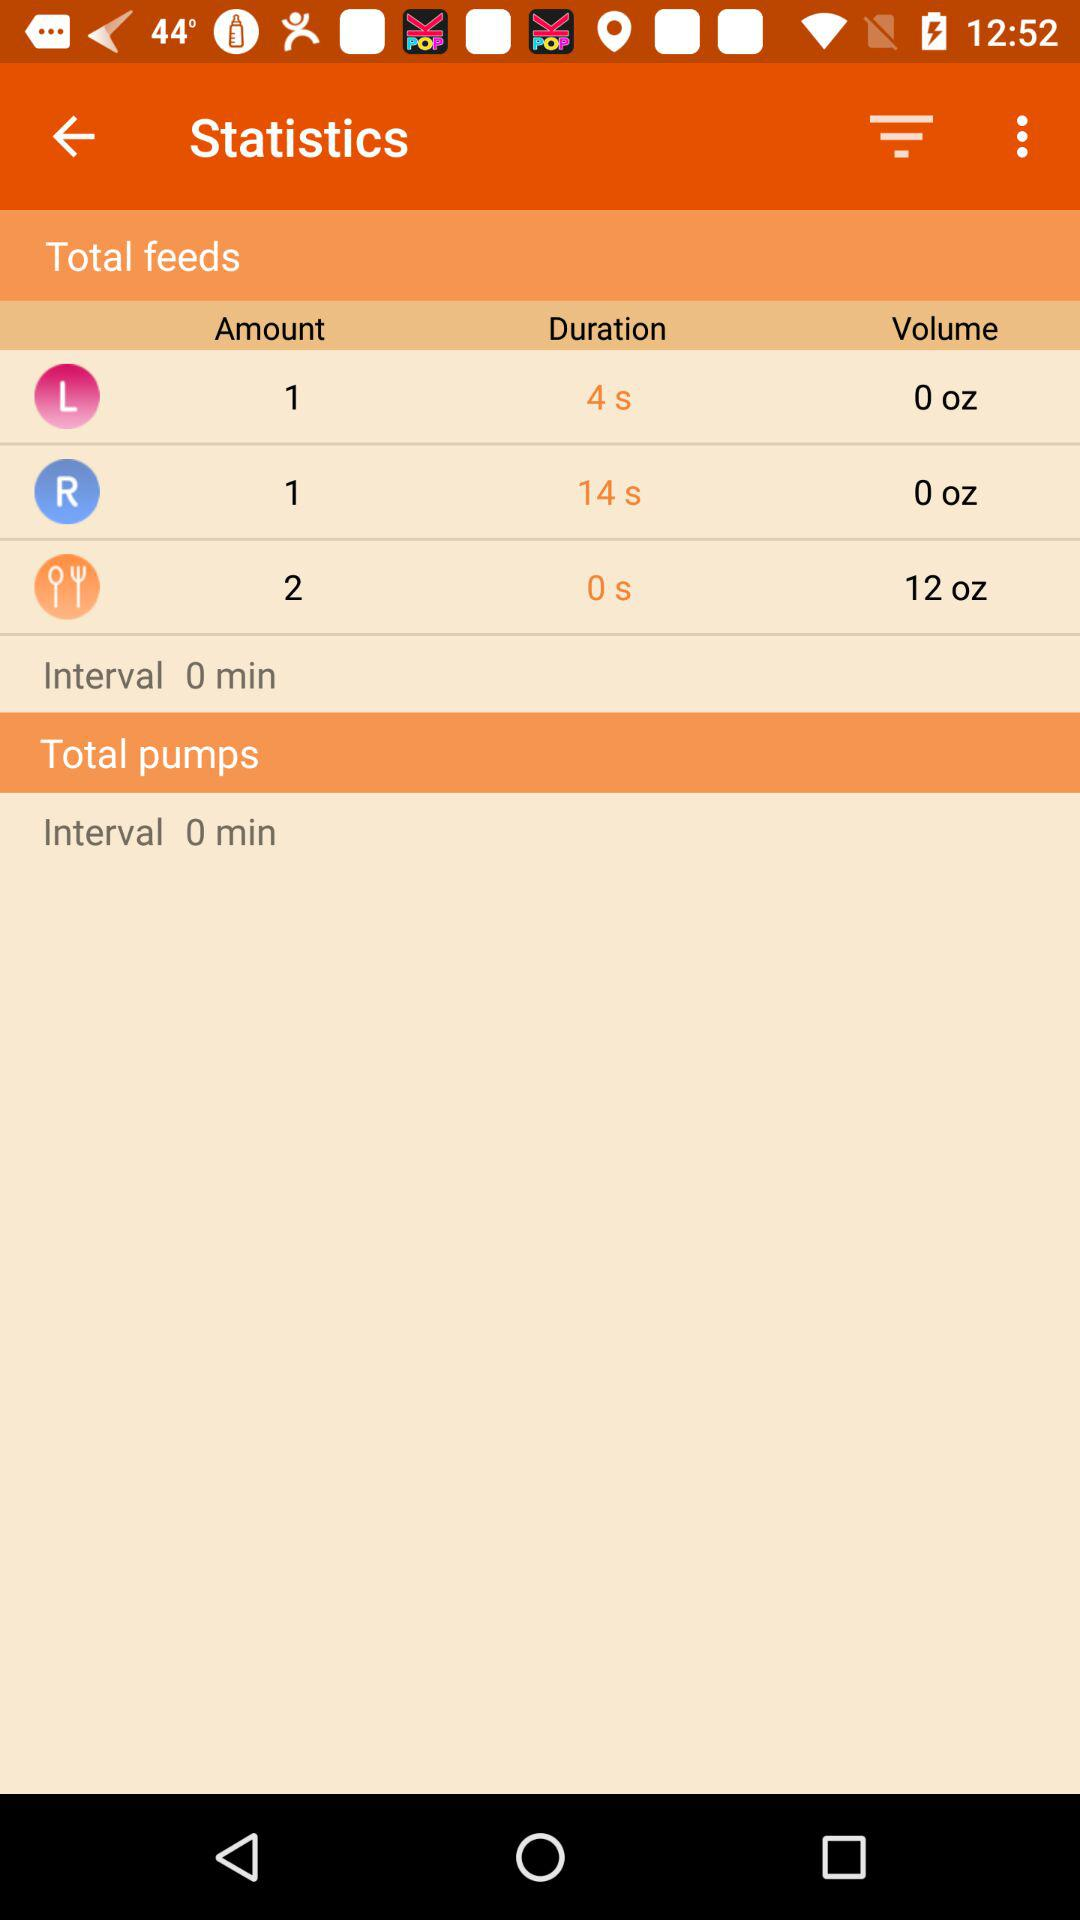What is the interval time? The interval time is 0 minutes. 